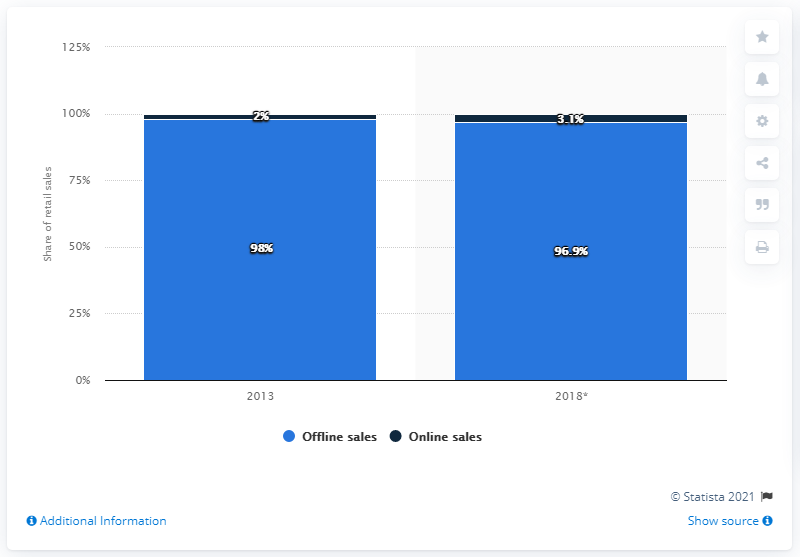Draw attention to some important aspects in this diagram. By 2018, online sales of home and garden products in Germany are predicted to increase by 3.1%. In 2013, online sales accounted for 2 percent of the retail sales of home and garden products in Germany. 